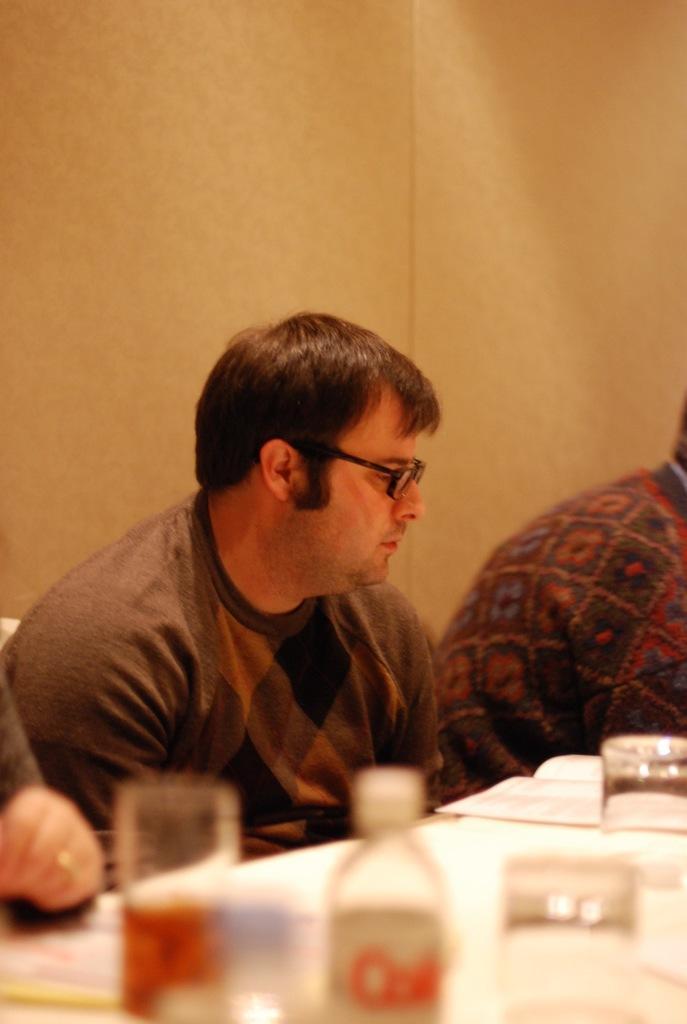Please provide a concise description of this image. In this image there are three people sitting on the chairs. In front of them there is a table. On top of it there are glasses, bottle and papers. Behind them there is a wall. 